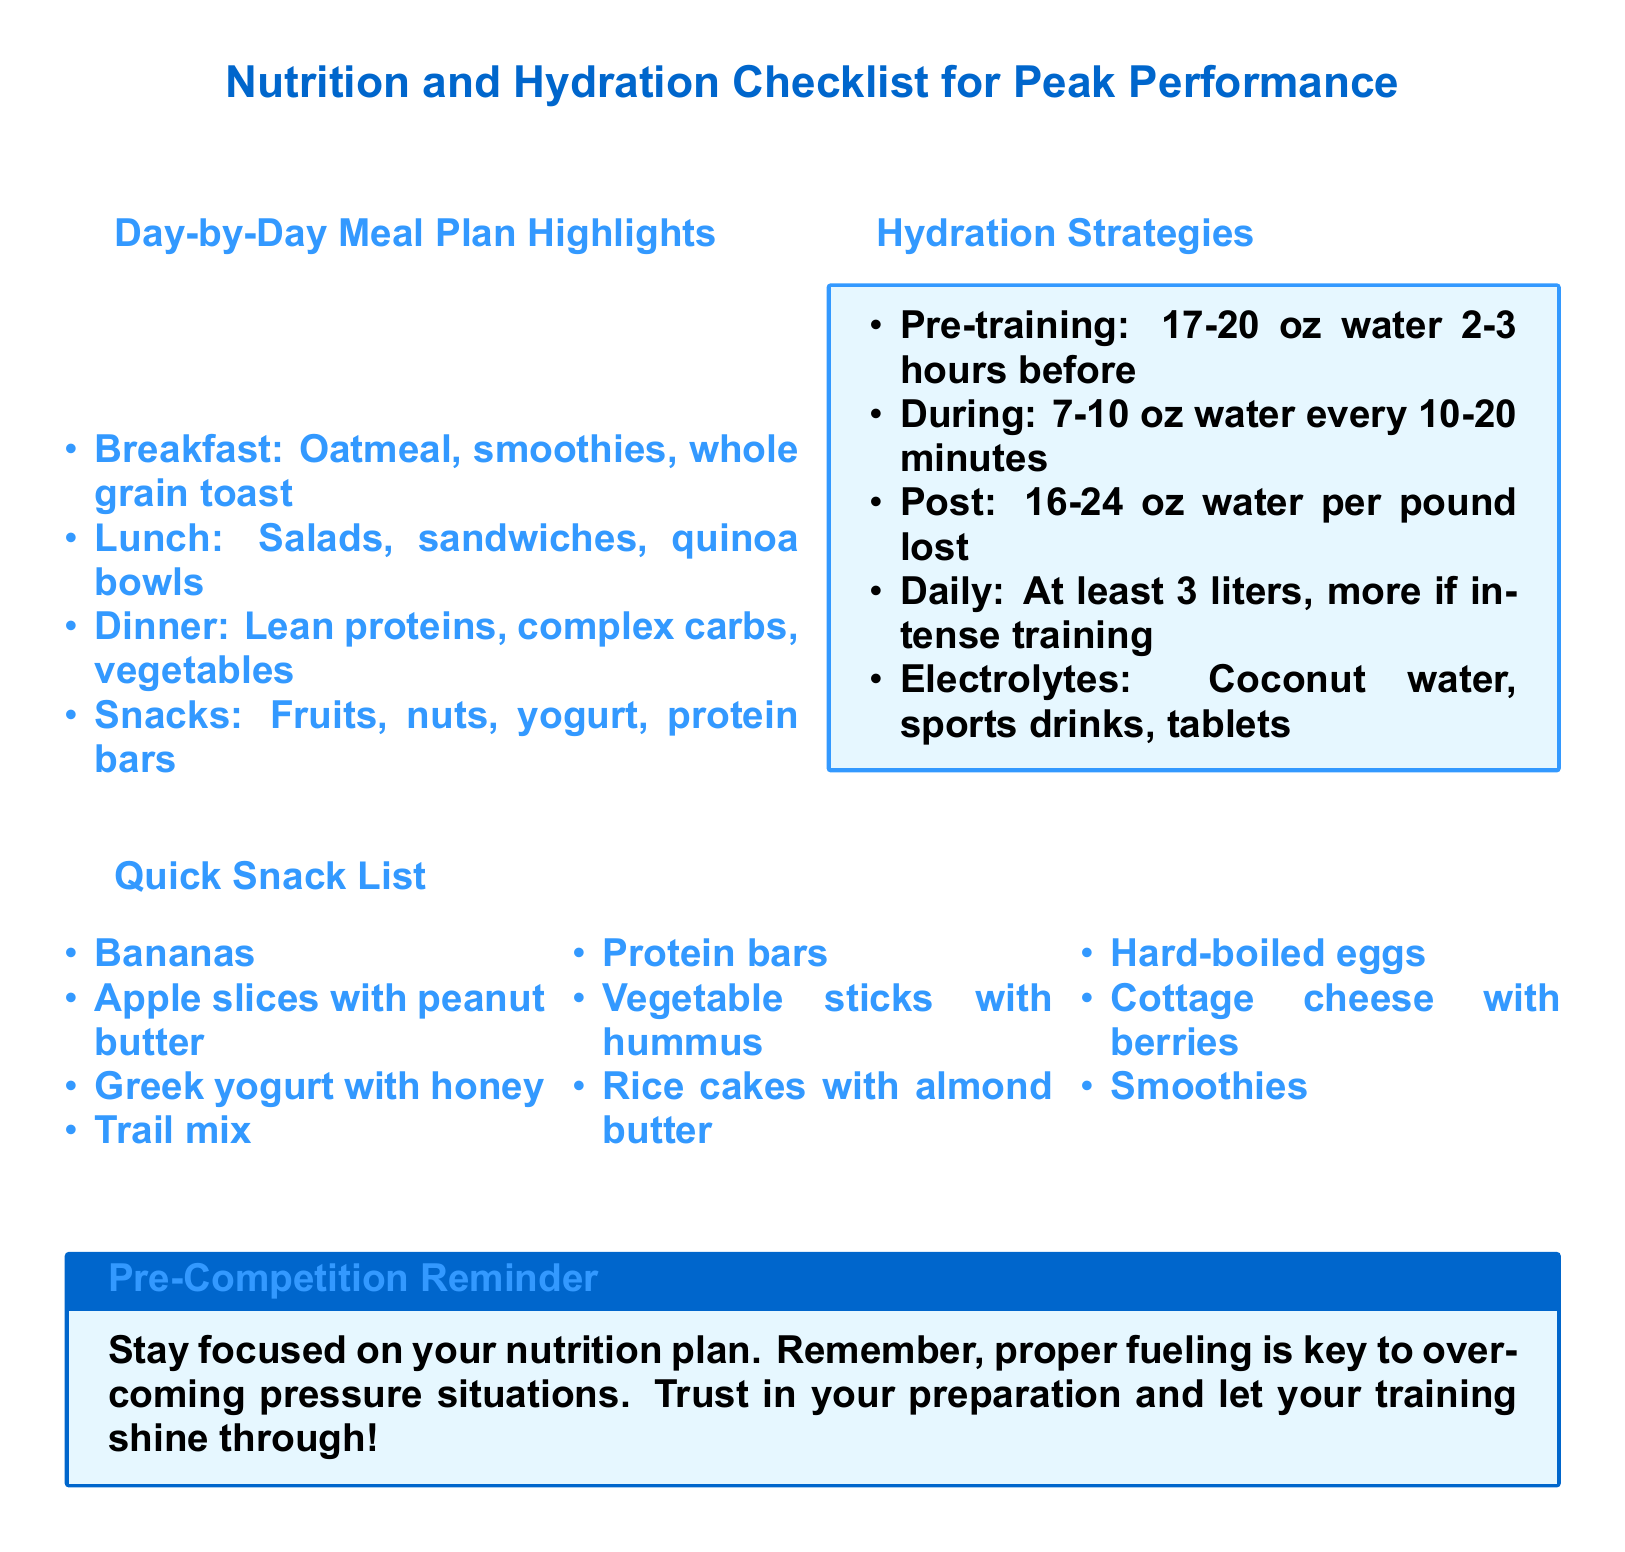what are the breakfast options listed? The breakfast options are highlighted in the 'Day-by-Day Meal Plan Highlights' section, which includes oatmeal, smoothies, and whole grain toast.
Answer: oatmeal, smoothies, whole grain toast how much water should be consumed pre-training? The document specifies that 17-20 oz of water should be consumed 2-3 hours before training.
Answer: 17-20 oz what is suggested for snacks? The snack list contains various options that are easy to prepare, and it is mentioned in the 'Quick Snack List' section.
Answer: fruits, nuts, yogurt, protein bars how often should water be consumed during training? The hydration strategies indicate that 7-10 oz of water should be consumed every 10-20 minutes during training.
Answer: every 10-20 minutes what should be the daily water intake? According to the hydration strategies, at least 3 liters of water should be consumed daily, with more required if training is intense.
Answer: at least 3 liters what is the purpose of the pre-competition reminder? The pre-competition reminder emphasizes the importance of following the nutrition plan to help overcome pressure situations, focusing on fueling properly.
Answer: proper fueling what is one example of an electrolyte source? The document lists options for electrolyte intake, including coconut water.
Answer: coconut water which carbohydrate source is mentioned for dinner? The 'Day-by-Day Meal Plan Highlights' section provides examples of complex carbs to be included in dinner, one of which is quinoa.
Answer: quinoa 